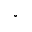<formula> <loc_0><loc_0><loc_500><loc_500>^ { \circ }</formula> 